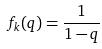Convert formula to latex. <formula><loc_0><loc_0><loc_500><loc_500>f _ { k } ( q ) = \frac { 1 } { 1 - q }</formula> 